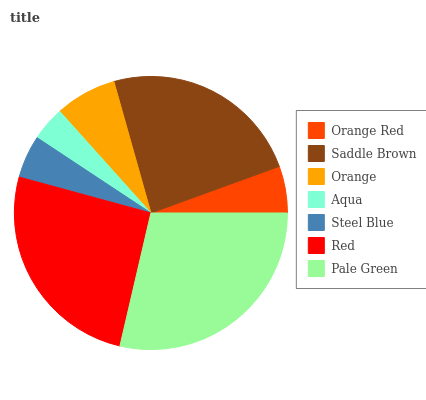Is Aqua the minimum?
Answer yes or no. Yes. Is Pale Green the maximum?
Answer yes or no. Yes. Is Saddle Brown the minimum?
Answer yes or no. No. Is Saddle Brown the maximum?
Answer yes or no. No. Is Saddle Brown greater than Orange Red?
Answer yes or no. Yes. Is Orange Red less than Saddle Brown?
Answer yes or no. Yes. Is Orange Red greater than Saddle Brown?
Answer yes or no. No. Is Saddle Brown less than Orange Red?
Answer yes or no. No. Is Orange the high median?
Answer yes or no. Yes. Is Orange the low median?
Answer yes or no. Yes. Is Red the high median?
Answer yes or no. No. Is Saddle Brown the low median?
Answer yes or no. No. 